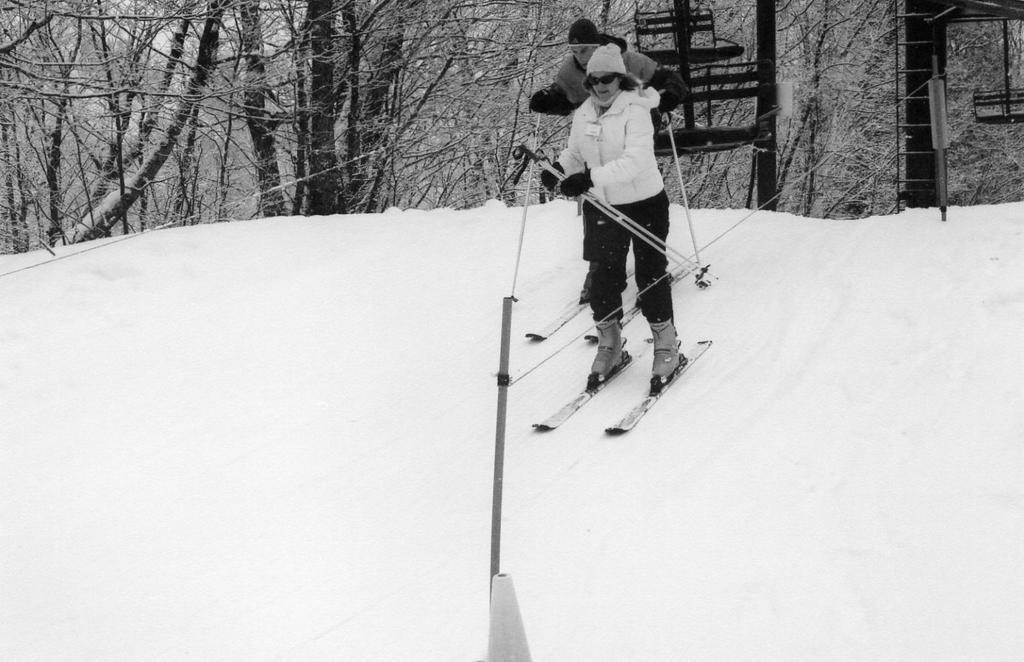Can you describe this image briefly? A man and woman are skating on snow. Behind them there are trees. 